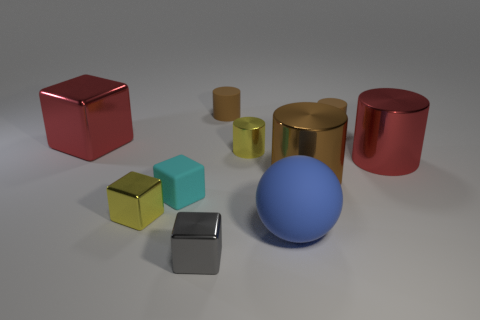There is a object that is the same color as the tiny metallic cylinder; what size is it?
Offer a very short reply. Small. Is the cyan matte thing the same size as the yellow cylinder?
Give a very brief answer. Yes. Is there a yellow object that has the same size as the yellow shiny block?
Provide a short and direct response. Yes. What material is the red object that is behind the red cylinder?
Your response must be concise. Metal. What color is the tiny cylinder that is made of the same material as the red block?
Make the answer very short. Yellow. What number of rubber objects are either large red cylinders or tiny yellow cubes?
Provide a succinct answer. 0. The yellow object that is the same size as the yellow cube is what shape?
Offer a terse response. Cylinder. What number of objects are either tiny metallic cubes behind the small gray shiny object or things that are left of the gray object?
Make the answer very short. 3. What material is the cylinder that is the same size as the brown shiny thing?
Provide a succinct answer. Metal. What number of other things are made of the same material as the red block?
Your response must be concise. 5. 